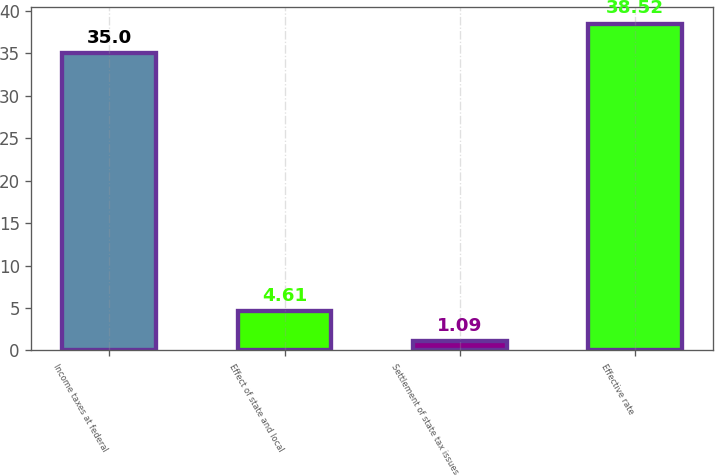<chart> <loc_0><loc_0><loc_500><loc_500><bar_chart><fcel>Income taxes at federal<fcel>Effect of state and local<fcel>Settlement of state tax issues<fcel>Effective rate<nl><fcel>35<fcel>4.61<fcel>1.09<fcel>38.52<nl></chart> 